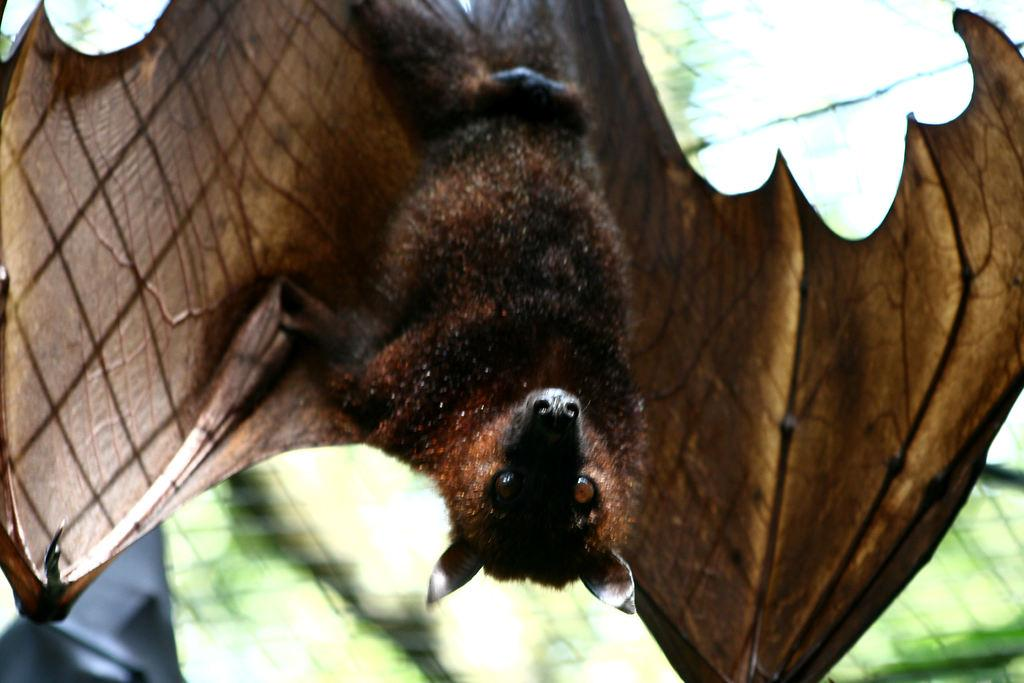What animal is present in the image? There is a bat in the image. Can you describe the background of the image? The background of the image is blurred. What type of hole can be seen in the image? There is no hole present in the image; it features a bat and a blurred background. 